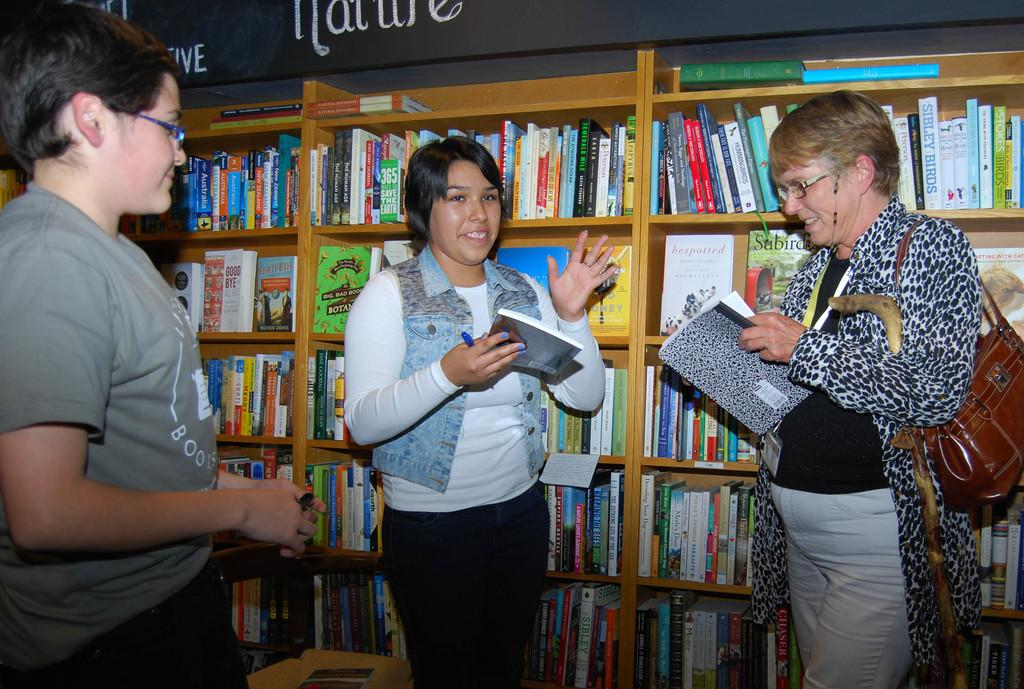<image>
Share a concise interpretation of the image provided. One of the books on the shelf between the two people holding books is titled bespotted. 